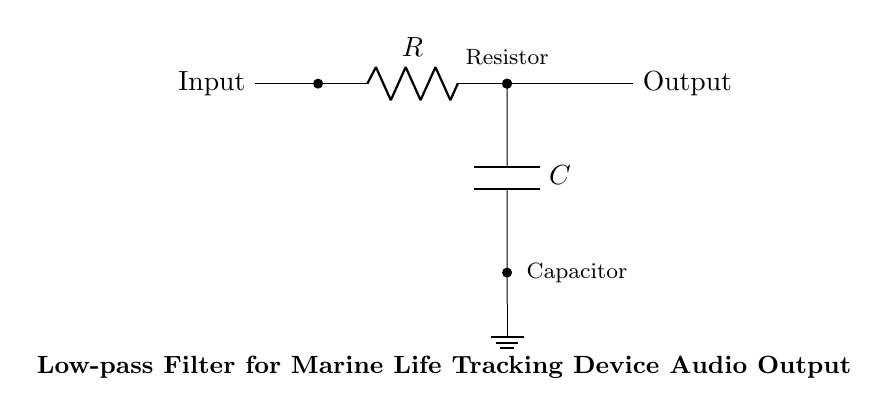What components are present in the circuit? The circuit includes a resistor and a capacitor. These components are essential for forming the low-pass filter.
Answer: Resistor and Capacitor What does the input signal connect to? The input signal connects directly to the resistor, which is the first component in the filter circuit. This connection allows the input signal to flow into the resistor for processing.
Answer: Resistor What type of filter is represented in the circuit? The circuit is a low-pass filter, which means it allows low-frequency signals to pass through while attenuating high-frequency signals. This characteristic is crucial for audio output in the context of marine life tracking.
Answer: Low-pass filter What is the role of the capacitor in the circuit? The capacitor stores and releases energy, smoothing out the output signal by filtering out high frequencies. This action is integral to the functioning of the low-pass filter, allowing it to produce a cleaner audio output.
Answer: Smoothing output signal Where does the output signal come from in the circuit? The output signal originates from the junction between the resistor and capacitor, indicating that it represents the processed audio signal after the filtering effect has taken place.
Answer: Between Resistor and Capacitor What happens to high-frequency signals in this circuit? High-frequency signals are attenuated, meaning they are reduced in amplitude as they attempt to pass through the low-pass filter. This functionality helps to isolate the desired audio signal by minimizing unwanted frequencies.
Answer: Attenuated 